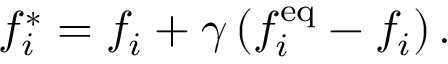<formula> <loc_0><loc_0><loc_500><loc_500>f _ { i } ^ { * } = f _ { i } + \gamma \left ( f _ { i } ^ { e q } - f _ { i } \right ) .</formula> 